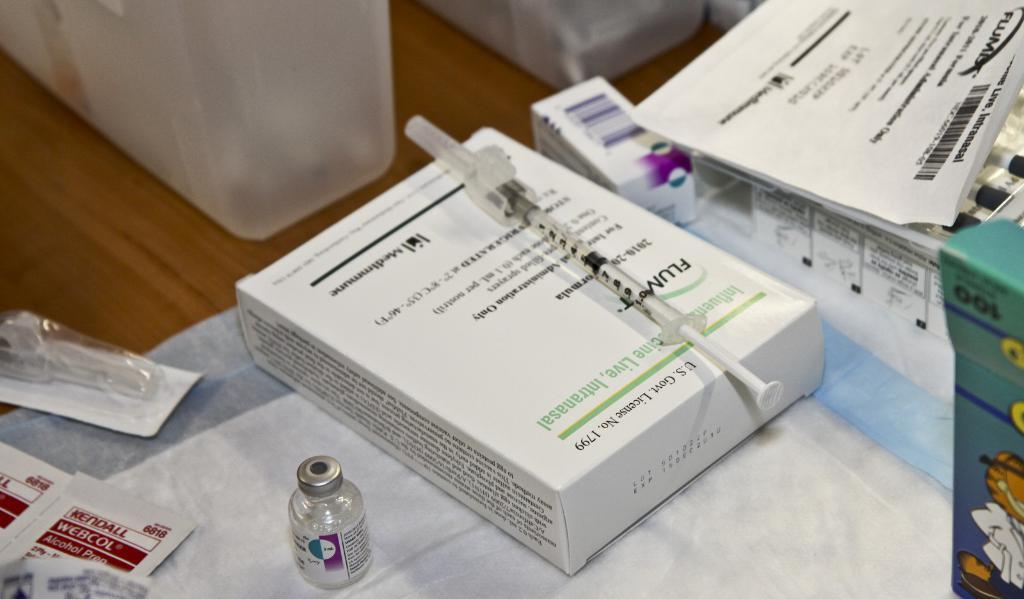<image>
Share a concise interpretation of the image provided. A syringe and a box with the title U.S. Govt. License No. 1799. 